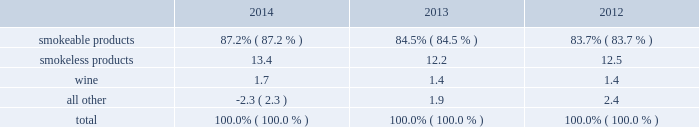Part i item 1 .
Business .
General development of business general : altria group , inc .
Is a holding company incorporated in the commonwealth of virginia in 1985 .
At december 31 , 2014 , altria group , inc . 2019s wholly-owned subsidiaries included philip morris usa inc .
( 201cpm usa 201d ) , which is engaged predominantly in the manufacture and sale of cigarettes in the united states ; john middleton co .
( 201cmiddleton 201d ) , which is engaged in the manufacture and sale of machine-made large cigars and pipe tobacco , and is a wholly- owned subsidiary of pm usa ; and ust llc ( 201cust 201d ) , which through its wholly-owned subsidiaries , including u.s .
Smokeless tobacco company llc ( 201cusstc 201d ) and ste .
Michelle wine estates ltd .
( 201cste .
Michelle 201d ) , is engaged in the manufacture and sale of smokeless tobacco products and wine .
Altria group , inc . 2019s other operating companies included nu mark llc ( 201cnu mark 201d ) , a wholly-owned subsidiary that is engaged in the manufacture and sale of innovative tobacco products , and philip morris capital corporation ( 201cpmcc 201d ) , a wholly-owned subsidiary that maintains a portfolio of finance assets , substantially all of which are leveraged leases .
Other altria group , inc .
Wholly-owned subsidiaries included altria group distribution company , which provides sales , distribution and consumer engagement services to certain altria group , inc .
Operating subsidiaries , and altria client services inc. , which provides various support services , such as legal , regulatory , finance , human resources and external affairs , to altria group , inc .
And its subsidiaries .
At december 31 , 2014 , altria group , inc .
Also held approximately 27% ( 27 % ) of the economic and voting interest of sabmiller plc ( 201csabmiller 201d ) , which altria group , inc .
Accounts for under the equity method of accounting .
Source of funds : because altria group , inc .
Is a holding company , its access to the operating cash flows of its wholly- owned subsidiaries consists of cash received from the payment of dividends and distributions , and the payment of interest on intercompany loans by its subsidiaries .
At december 31 , 2014 , altria group , inc . 2019s principal wholly-owned subsidiaries were not limited by long-term debt or other agreements in their ability to pay cash dividends or make other distributions with respect to their equity interests .
In addition , altria group , inc .
Receives cash dividends on its interest in sabmiller if and when sabmiller pays such dividends .
Financial information about segments altria group , inc . 2019s reportable segments are smokeable products , smokeless products and wine .
The financial services and the innovative tobacco products businesses are included in an all other category due to the continued reduction of the lease portfolio of pmcc and the relative financial contribution of altria group , inc . 2019s innovative tobacco products businesses to altria group , inc . 2019s consolidated results .
Altria group , inc . 2019s chief operating decision maker reviews operating companies income to evaluate the performance of , and allocate resources to , the segments .
Operating companies income for the segments is defined as operating income before amortization of intangibles and general corporate expenses .
Interest and other debt expense , net , and provision for income taxes are centrally managed at the corporate level and , accordingly , such items are not presented by segment since they are excluded from the measure of segment profitability reviewed by altria group , inc . 2019s chief operating decision maker .
Net revenues and operating companies income ( together with a reconciliation to earnings before income taxes ) attributable to each such segment for each of the last three years are set forth in note 15 .
Segment reporting to the consolidated financial statements in item 8 .
Financial statements and supplementary data of this annual report on form 10-k ( 201citem 8 201d ) .
Information about total assets by segment is not disclosed because such information is not reported to or used by altria group , inc . 2019s chief operating decision maker .
Segment goodwill and other intangible assets , net , are disclosed in note 4 .
Goodwill and other intangible assets , net to the consolidated financial statements in item 8 ( 201cnote 4 201d ) .
The accounting policies of the segments are the same as those described in note 2 .
Summary of significant accounting policies to the consolidated financial statements in item 8 ( 201cnote 2 201d ) .
The relative percentages of operating companies income ( loss ) attributable to each reportable segment and the all other category were as follows: .
For items affecting the comparability of the relative percentages of operating companies income ( loss ) attributable to each reportable segment , see note 15 .
Segment reporting to the consolidated financial statements in item 8 ( 201cnote 15 201d ) .
Narrative description of business portions of the information called for by this item are included in item 7 .
Management 2019s discussion and analysis of financial condition and results of operations - operating results by business segment of this annual report on form 10-k .
Tobacco space altria group , inc . 2019s tobacco operating companies include pm usa , usstc and other subsidiaries of ust , middleton and nu mark .
Altria group distribution company provides sales , distribution and consumer engagement services to altria group , inc . 2019s tobacco operating companies .
The products of altria group , inc . 2019s tobacco subsidiaries include smokeable tobacco products comprised of cigarettes manufactured and sold by pm usa and machine-made large altria_mdc_2014form10k_nolinks_crops.pdf 3 2/25/15 5:56 pm .
How did the percentage of operating income related to smokeless product change from 2013 to 2014 relative the total operating income? 
Computations: ((13.4 - 12.2) / 12.2)
Answer: 0.09836. 